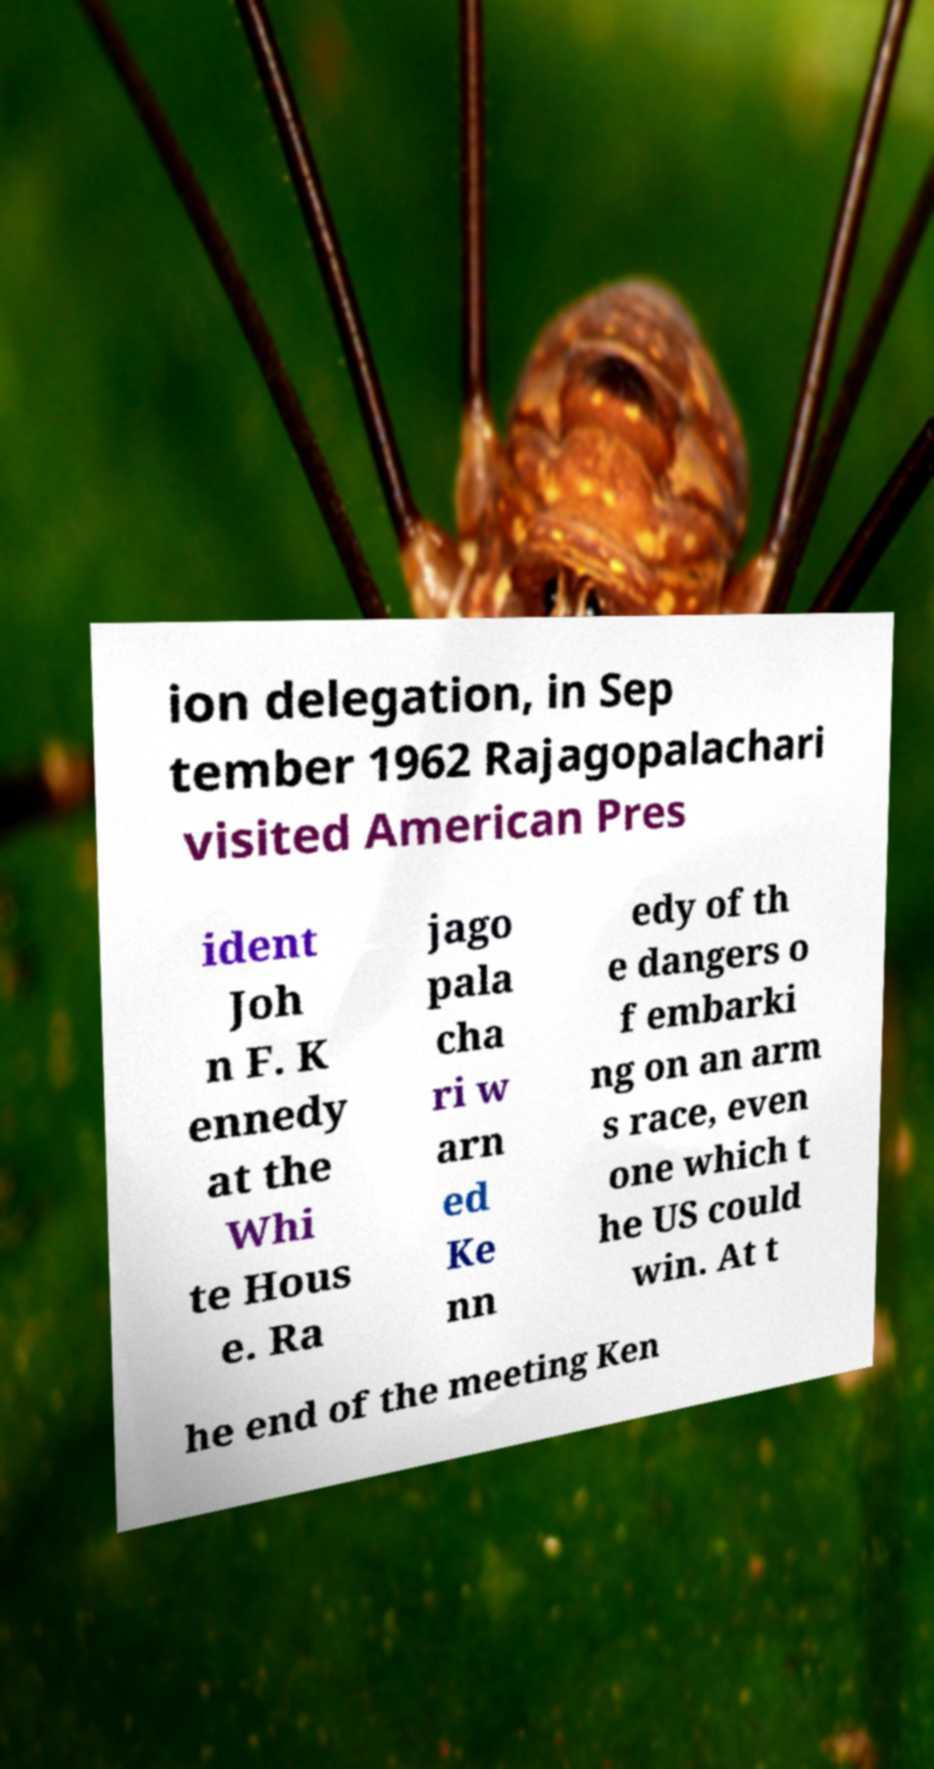Can you accurately transcribe the text from the provided image for me? ion delegation, in Sep tember 1962 Rajagopalachari visited American Pres ident Joh n F. K ennedy at the Whi te Hous e. Ra jago pala cha ri w arn ed Ke nn edy of th e dangers o f embarki ng on an arm s race, even one which t he US could win. At t he end of the meeting Ken 